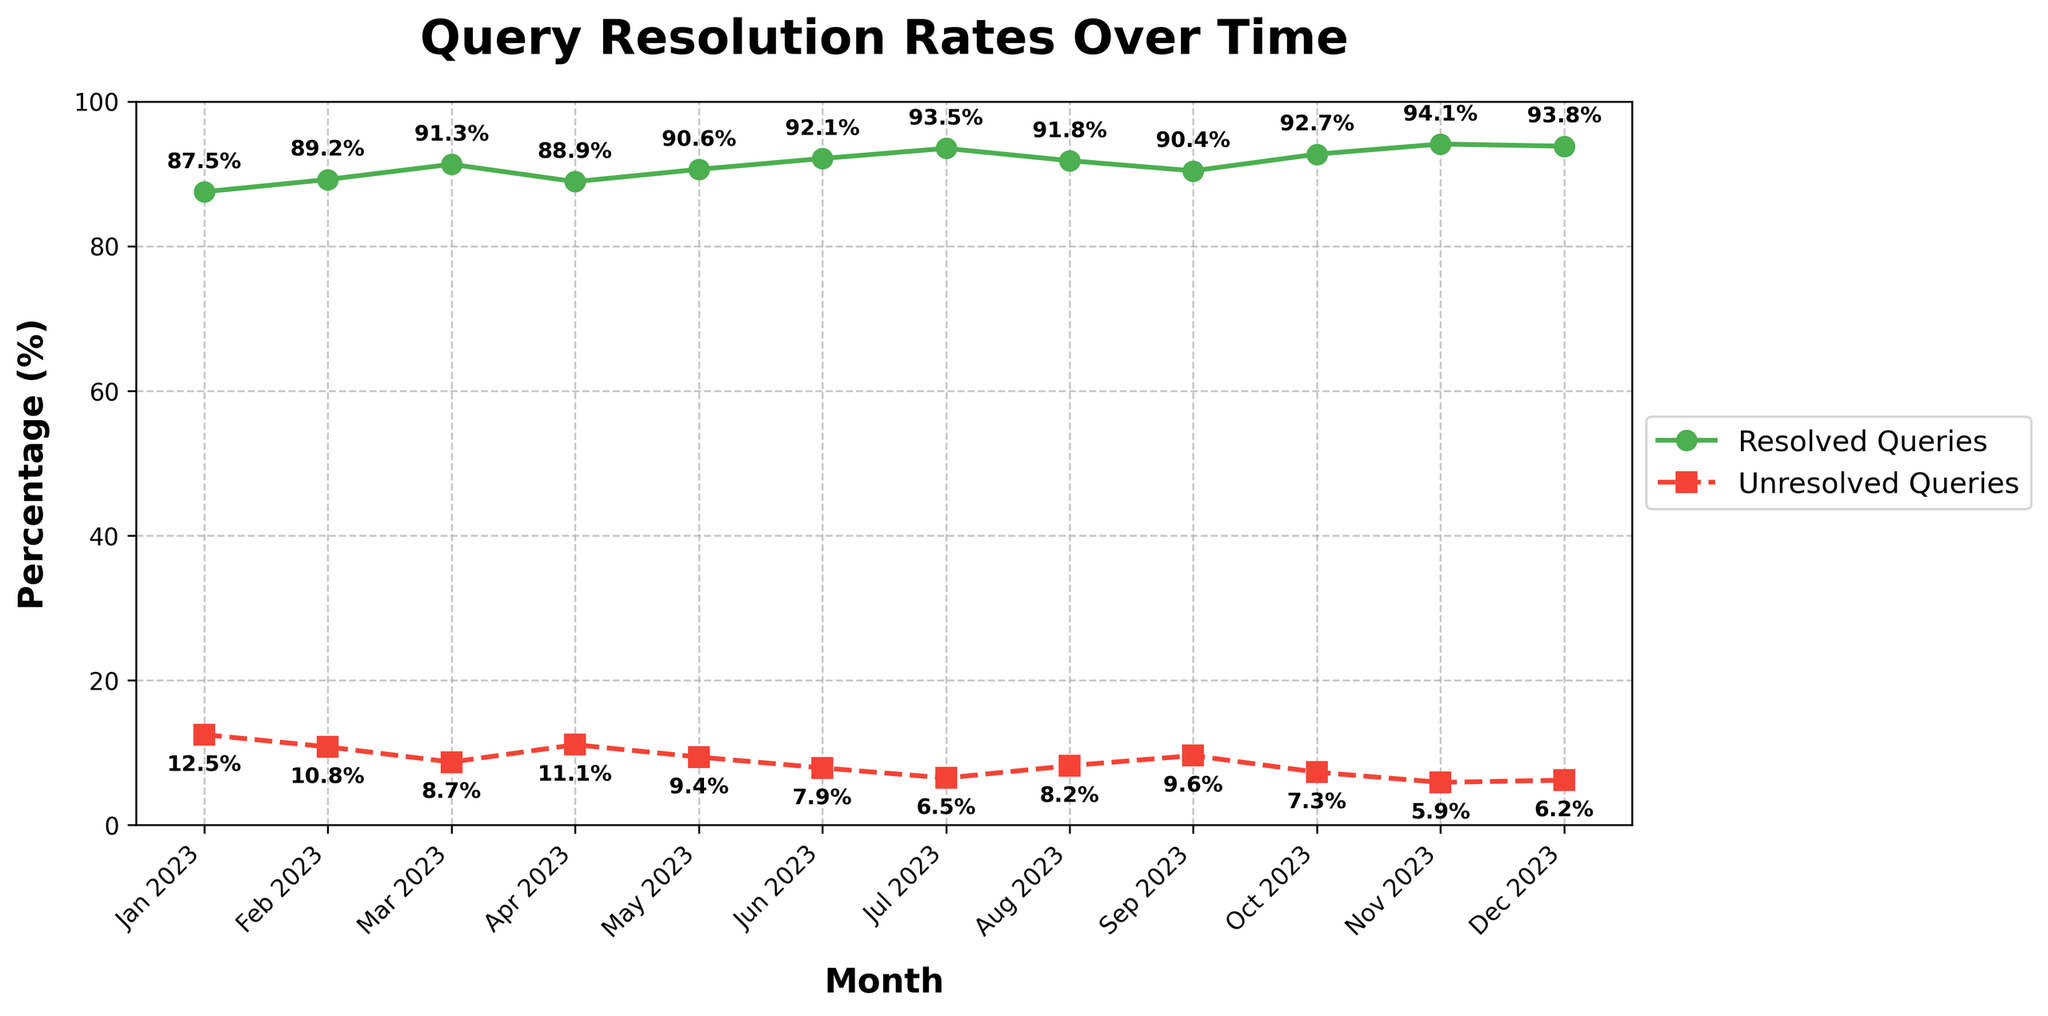What are the months where unresolved queries were below 8%? Look at the plot and find months where the unresolved queries line is below the 8% mark. These months are June, July, October, November, and December.
Answer: June, July, October, November, December What is the highest percentage of resolved queries, and in which month? Identify the highest point on the resolved queries line. It occurs in November at 94.1%.
Answer: 94.1%, November How did the percentage of unresolved queries change from January to December? To see the change, we need to compare the values at January and December. Unresolved queries decreased from 12.5% in January to 6.2% in December, indicating a reduction.
Answer: Decreased Compare the average percentages of resolved and unresolved queries across the year. Which one is higher? Calculate the average of the resolved and unresolved queries across the 12 months. The average resolved percentage is higher (91.4%) compared to the average unresolved percentage (8.6%).
Answer: Resolved queries Identify the months where resolved queries exhibited a declining trend. Check the resolved queries line and note months where the value decreases from the previous month. This occurs in April and September.
Answer: April, September Which month has the smallest percentage of unresolved queries? Find the lowest point on the unresolved queries line. It occurs in November at 5.9%.
Answer: November What is the difference in the percentage of resolved queries between May and July? Subtract the percentage in May from the percentage in July. \(93.5% - 90.6% = 2.9%\)
Answer: 2.9% What colors are used to differentiate between resolved and unresolved queries? Observe the colors of the lines; resolved queries are shown in green and unresolved queries in red.
Answer: Green for resolved, Red for unresolved How does the percentage of unresolved queries in March compare to that in September? Compare the data points for March (8.7%) and September (9.6%), showing that September has a higher percentage.
Answer: Higher in September What is the trend in resolved queries from June to August? Observe the resolved queries line from June, July to August. It increases from 92.1% to 93.5%, then decreases slightly to 91.8%.
Answer: Increase, then slight decrease 